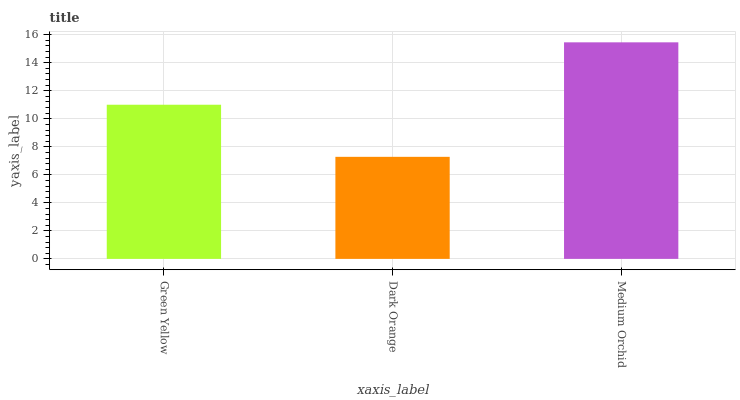Is Dark Orange the minimum?
Answer yes or no. Yes. Is Medium Orchid the maximum?
Answer yes or no. Yes. Is Medium Orchid the minimum?
Answer yes or no. No. Is Dark Orange the maximum?
Answer yes or no. No. Is Medium Orchid greater than Dark Orange?
Answer yes or no. Yes. Is Dark Orange less than Medium Orchid?
Answer yes or no. Yes. Is Dark Orange greater than Medium Orchid?
Answer yes or no. No. Is Medium Orchid less than Dark Orange?
Answer yes or no. No. Is Green Yellow the high median?
Answer yes or no. Yes. Is Green Yellow the low median?
Answer yes or no. Yes. Is Dark Orange the high median?
Answer yes or no. No. Is Medium Orchid the low median?
Answer yes or no. No. 